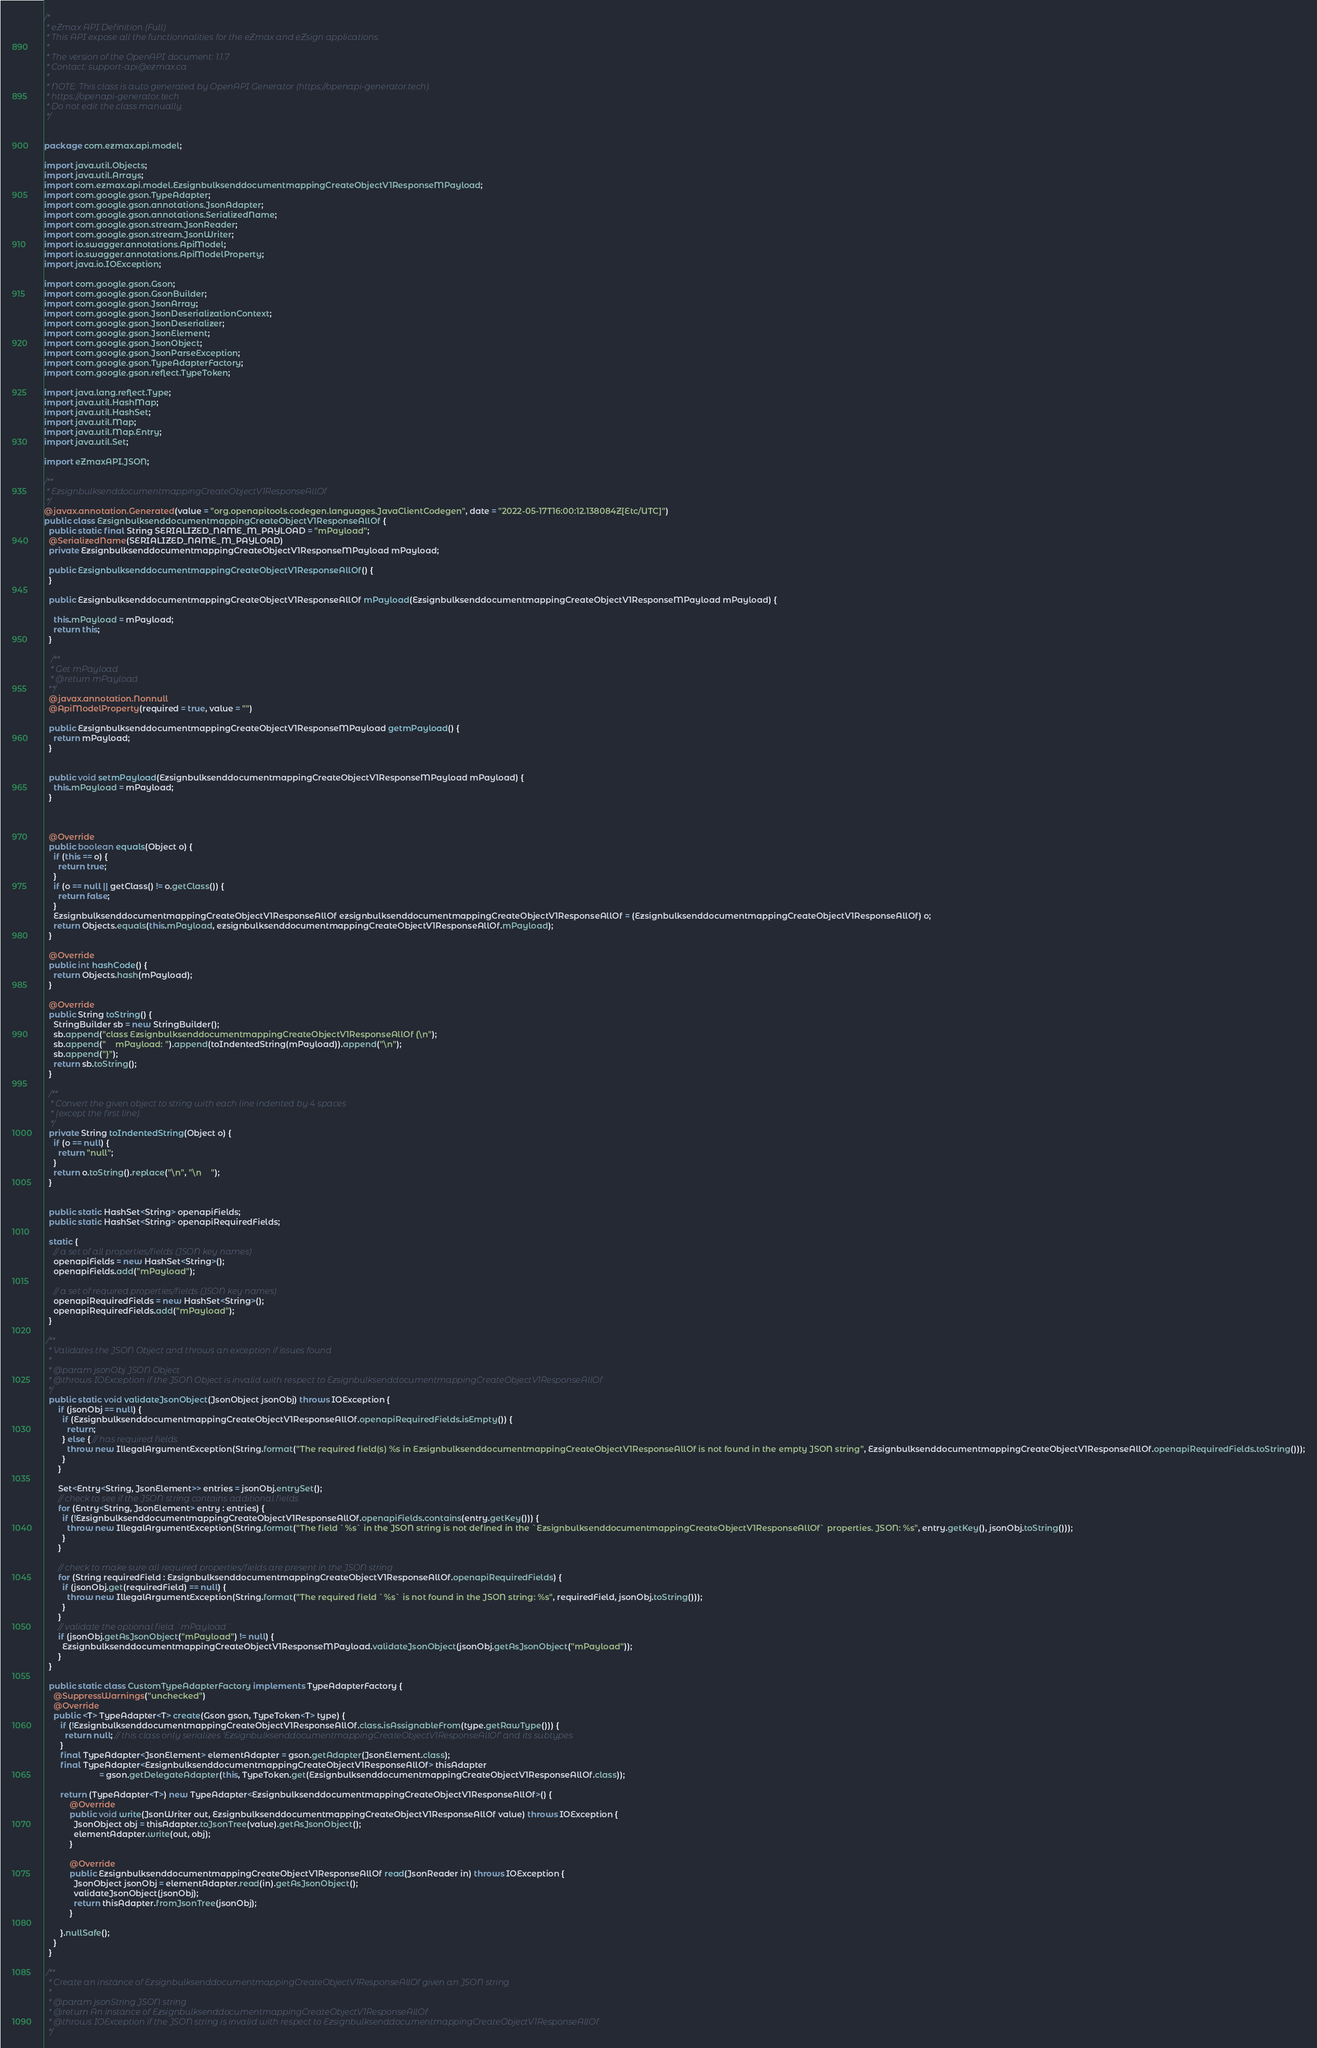<code> <loc_0><loc_0><loc_500><loc_500><_Java_>/*
 * eZmax API Definition (Full)
 * This API expose all the functionnalities for the eZmax and eZsign applications.
 *
 * The version of the OpenAPI document: 1.1.7
 * Contact: support-api@ezmax.ca
 *
 * NOTE: This class is auto generated by OpenAPI Generator (https://openapi-generator.tech).
 * https://openapi-generator.tech
 * Do not edit the class manually.
 */


package com.ezmax.api.model;

import java.util.Objects;
import java.util.Arrays;
import com.ezmax.api.model.EzsignbulksenddocumentmappingCreateObjectV1ResponseMPayload;
import com.google.gson.TypeAdapter;
import com.google.gson.annotations.JsonAdapter;
import com.google.gson.annotations.SerializedName;
import com.google.gson.stream.JsonReader;
import com.google.gson.stream.JsonWriter;
import io.swagger.annotations.ApiModel;
import io.swagger.annotations.ApiModelProperty;
import java.io.IOException;

import com.google.gson.Gson;
import com.google.gson.GsonBuilder;
import com.google.gson.JsonArray;
import com.google.gson.JsonDeserializationContext;
import com.google.gson.JsonDeserializer;
import com.google.gson.JsonElement;
import com.google.gson.JsonObject;
import com.google.gson.JsonParseException;
import com.google.gson.TypeAdapterFactory;
import com.google.gson.reflect.TypeToken;

import java.lang.reflect.Type;
import java.util.HashMap;
import java.util.HashSet;
import java.util.Map;
import java.util.Map.Entry;
import java.util.Set;

import eZmaxAPI.JSON;

/**
 * EzsignbulksenddocumentmappingCreateObjectV1ResponseAllOf
 */
@javax.annotation.Generated(value = "org.openapitools.codegen.languages.JavaClientCodegen", date = "2022-05-17T16:00:12.138084Z[Etc/UTC]")
public class EzsignbulksenddocumentmappingCreateObjectV1ResponseAllOf {
  public static final String SERIALIZED_NAME_M_PAYLOAD = "mPayload";
  @SerializedName(SERIALIZED_NAME_M_PAYLOAD)
  private EzsignbulksenddocumentmappingCreateObjectV1ResponseMPayload mPayload;

  public EzsignbulksenddocumentmappingCreateObjectV1ResponseAllOf() { 
  }

  public EzsignbulksenddocumentmappingCreateObjectV1ResponseAllOf mPayload(EzsignbulksenddocumentmappingCreateObjectV1ResponseMPayload mPayload) {
    
    this.mPayload = mPayload;
    return this;
  }

   /**
   * Get mPayload
   * @return mPayload
  **/
  @javax.annotation.Nonnull
  @ApiModelProperty(required = true, value = "")

  public EzsignbulksenddocumentmappingCreateObjectV1ResponseMPayload getmPayload() {
    return mPayload;
  }


  public void setmPayload(EzsignbulksenddocumentmappingCreateObjectV1ResponseMPayload mPayload) {
    this.mPayload = mPayload;
  }



  @Override
  public boolean equals(Object o) {
    if (this == o) {
      return true;
    }
    if (o == null || getClass() != o.getClass()) {
      return false;
    }
    EzsignbulksenddocumentmappingCreateObjectV1ResponseAllOf ezsignbulksenddocumentmappingCreateObjectV1ResponseAllOf = (EzsignbulksenddocumentmappingCreateObjectV1ResponseAllOf) o;
    return Objects.equals(this.mPayload, ezsignbulksenddocumentmappingCreateObjectV1ResponseAllOf.mPayload);
  }

  @Override
  public int hashCode() {
    return Objects.hash(mPayload);
  }

  @Override
  public String toString() {
    StringBuilder sb = new StringBuilder();
    sb.append("class EzsignbulksenddocumentmappingCreateObjectV1ResponseAllOf {\n");
    sb.append("    mPayload: ").append(toIndentedString(mPayload)).append("\n");
    sb.append("}");
    return sb.toString();
  }

  /**
   * Convert the given object to string with each line indented by 4 spaces
   * (except the first line).
   */
  private String toIndentedString(Object o) {
    if (o == null) {
      return "null";
    }
    return o.toString().replace("\n", "\n    ");
  }


  public static HashSet<String> openapiFields;
  public static HashSet<String> openapiRequiredFields;

  static {
    // a set of all properties/fields (JSON key names)
    openapiFields = new HashSet<String>();
    openapiFields.add("mPayload");

    // a set of required properties/fields (JSON key names)
    openapiRequiredFields = new HashSet<String>();
    openapiRequiredFields.add("mPayload");
  }

 /**
  * Validates the JSON Object and throws an exception if issues found
  *
  * @param jsonObj JSON Object
  * @throws IOException if the JSON Object is invalid with respect to EzsignbulksenddocumentmappingCreateObjectV1ResponseAllOf
  */
  public static void validateJsonObject(JsonObject jsonObj) throws IOException {
      if (jsonObj == null) {
        if (EzsignbulksenddocumentmappingCreateObjectV1ResponseAllOf.openapiRequiredFields.isEmpty()) {
          return;
        } else { // has required fields
          throw new IllegalArgumentException(String.format("The required field(s) %s in EzsignbulksenddocumentmappingCreateObjectV1ResponseAllOf is not found in the empty JSON string", EzsignbulksenddocumentmappingCreateObjectV1ResponseAllOf.openapiRequiredFields.toString()));
        }
      }

      Set<Entry<String, JsonElement>> entries = jsonObj.entrySet();
      // check to see if the JSON string contains additional fields
      for (Entry<String, JsonElement> entry : entries) {
        if (!EzsignbulksenddocumentmappingCreateObjectV1ResponseAllOf.openapiFields.contains(entry.getKey())) {
          throw new IllegalArgumentException(String.format("The field `%s` in the JSON string is not defined in the `EzsignbulksenddocumentmappingCreateObjectV1ResponseAllOf` properties. JSON: %s", entry.getKey(), jsonObj.toString()));
        }
      }

      // check to make sure all required properties/fields are present in the JSON string
      for (String requiredField : EzsignbulksenddocumentmappingCreateObjectV1ResponseAllOf.openapiRequiredFields) {
        if (jsonObj.get(requiredField) == null) {
          throw new IllegalArgumentException(String.format("The required field `%s` is not found in the JSON string: %s", requiredField, jsonObj.toString()));
        }
      }
      // validate the optional field `mPayload`
      if (jsonObj.getAsJsonObject("mPayload") != null) {
        EzsignbulksenddocumentmappingCreateObjectV1ResponseMPayload.validateJsonObject(jsonObj.getAsJsonObject("mPayload"));
      }
  }

  public static class CustomTypeAdapterFactory implements TypeAdapterFactory {
    @SuppressWarnings("unchecked")
    @Override
    public <T> TypeAdapter<T> create(Gson gson, TypeToken<T> type) {
       if (!EzsignbulksenddocumentmappingCreateObjectV1ResponseAllOf.class.isAssignableFrom(type.getRawType())) {
         return null; // this class only serializes 'EzsignbulksenddocumentmappingCreateObjectV1ResponseAllOf' and its subtypes
       }
       final TypeAdapter<JsonElement> elementAdapter = gson.getAdapter(JsonElement.class);
       final TypeAdapter<EzsignbulksenddocumentmappingCreateObjectV1ResponseAllOf> thisAdapter
                        = gson.getDelegateAdapter(this, TypeToken.get(EzsignbulksenddocumentmappingCreateObjectV1ResponseAllOf.class));

       return (TypeAdapter<T>) new TypeAdapter<EzsignbulksenddocumentmappingCreateObjectV1ResponseAllOf>() {
           @Override
           public void write(JsonWriter out, EzsignbulksenddocumentmappingCreateObjectV1ResponseAllOf value) throws IOException {
             JsonObject obj = thisAdapter.toJsonTree(value).getAsJsonObject();
             elementAdapter.write(out, obj);
           }

           @Override
           public EzsignbulksenddocumentmappingCreateObjectV1ResponseAllOf read(JsonReader in) throws IOException {
             JsonObject jsonObj = elementAdapter.read(in).getAsJsonObject();
             validateJsonObject(jsonObj);
             return thisAdapter.fromJsonTree(jsonObj);
           }

       }.nullSafe();
    }
  }

 /**
  * Create an instance of EzsignbulksenddocumentmappingCreateObjectV1ResponseAllOf given an JSON string
  *
  * @param jsonString JSON string
  * @return An instance of EzsignbulksenddocumentmappingCreateObjectV1ResponseAllOf
  * @throws IOException if the JSON string is invalid with respect to EzsignbulksenddocumentmappingCreateObjectV1ResponseAllOf
  */</code> 